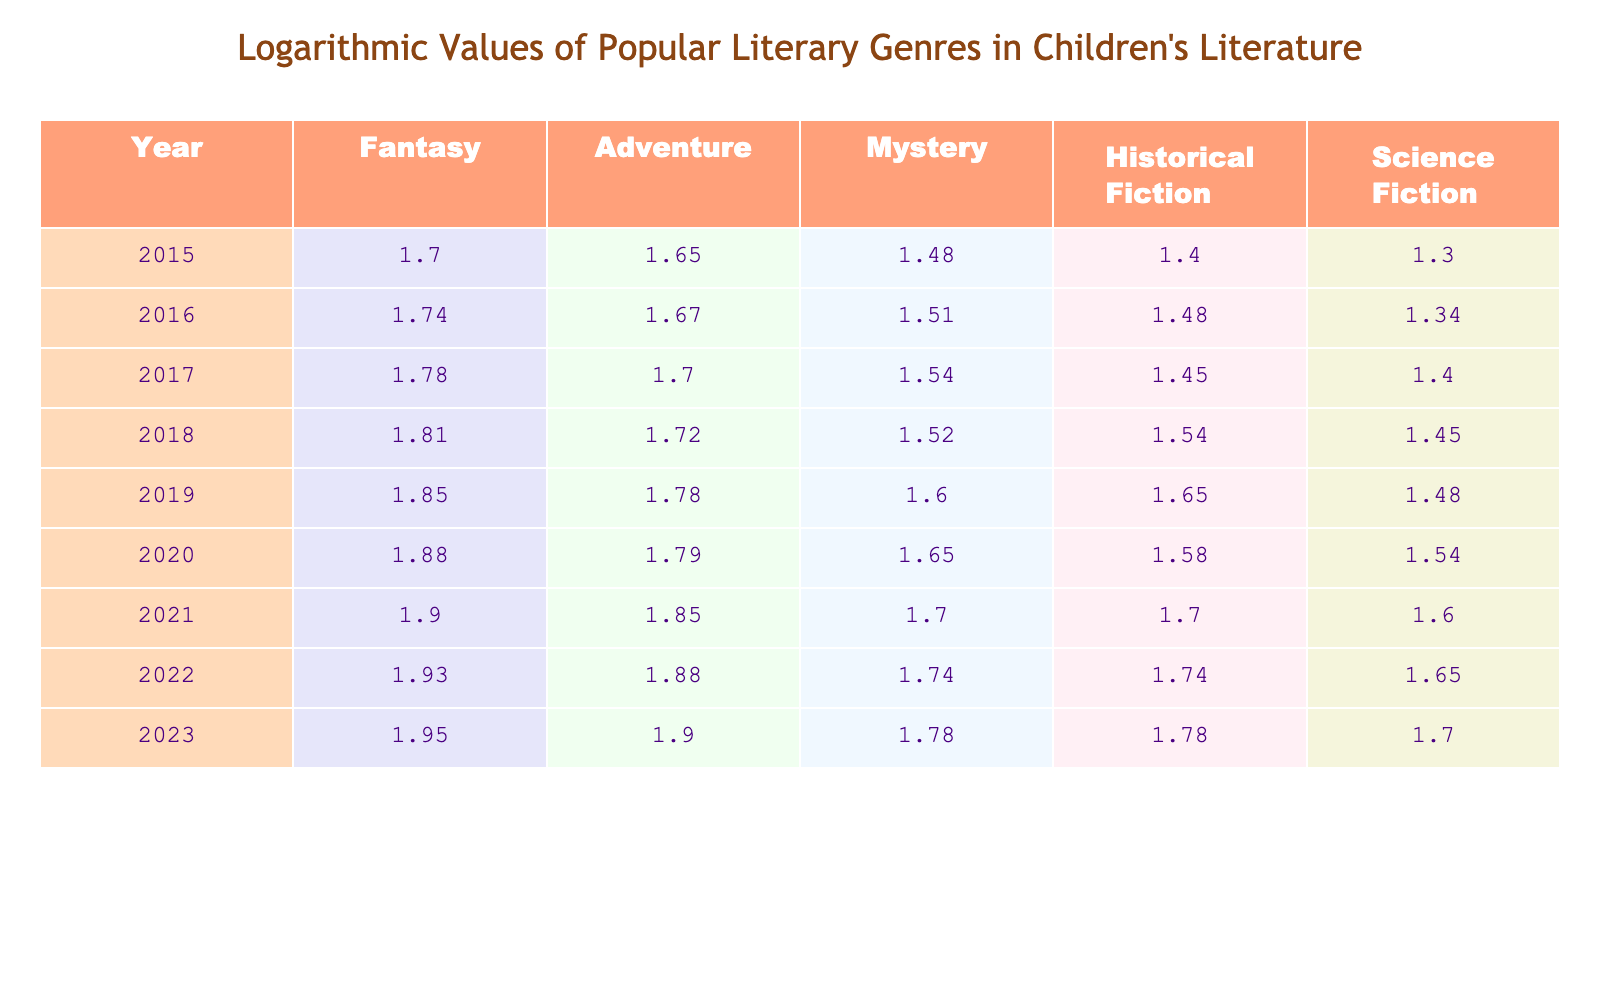What is the logarithmic value for the genre Fantasy in 2023? According to the table, the logarithmic value for the genre Fantasy in 2023 is directly listed as 1.954.
Answer: 1.954 What is the logarithmic value for Adventure in 2016? The table shows the logarithmic value for Adventure in 2016 as 1.672.
Answer: 1.672 Which genre had the highest logarithmic value in 2021? Looking across the columns for 2021, Fantasy has the highest value at 1.903, compared to others which are lower.
Answer: Fantasy Is the logarithmic value for Science Fiction in 2020 greater than that in 2019? In the table, Science Fiction in 2020 is represented as 1.544, while in 2019 it is 1.477. Since 1.544 is greater than 1.477, the statement is true.
Answer: Yes What was the increase in the logarithmic value of Mystery from 2018 to 2022? For 2018, the value is 1.519, and for 2022, it is 1.740. To find the increase, subtract 1.519 from 1.740, which results in 0.221.
Answer: 0.221 What is the average logarithmic value of Historical Fiction over the years provided? The values for Historical Fiction are 1.398, 1.477, 1.447, 1.544, 1.653, 1.699, 1.699, 1.740, 1.778. Adding them gives 13.542. There are 9 values, so the average is 13.542 / 9 = 1.5047.
Answer: 1.5047 Has the logarithmic value for Adventure consistently increased from 2015 to 2023? By checking the values for Adventure each year from 2015 to 2023, they are 1.653, 1.672, 1.699, 1.716, 1.778, 1.794, 1.806, 1.845, and 1.903, respectively. All values show a consistent increase; therefore, the answer is yes.
Answer: Yes What is the difference in logarithmic values of Fantasy between 2020 and 2019? The value for Fantasy in 2020 is 1.875, and in 2019, it is 1.845. The difference is calculated by subtracting 1.845 from 1.875, resulting in 0.030.
Answer: 0.030 What is the total logarithmic value for all genres combined in the year 2021? To find the total for 2021, we add the logarithmic values: Fantasy (1.903) + Adventure (1.845) + Mystery (1.699) + Historical Fiction (1.699) + Science Fiction (1.602), which totals 9.748.
Answer: 9.748 